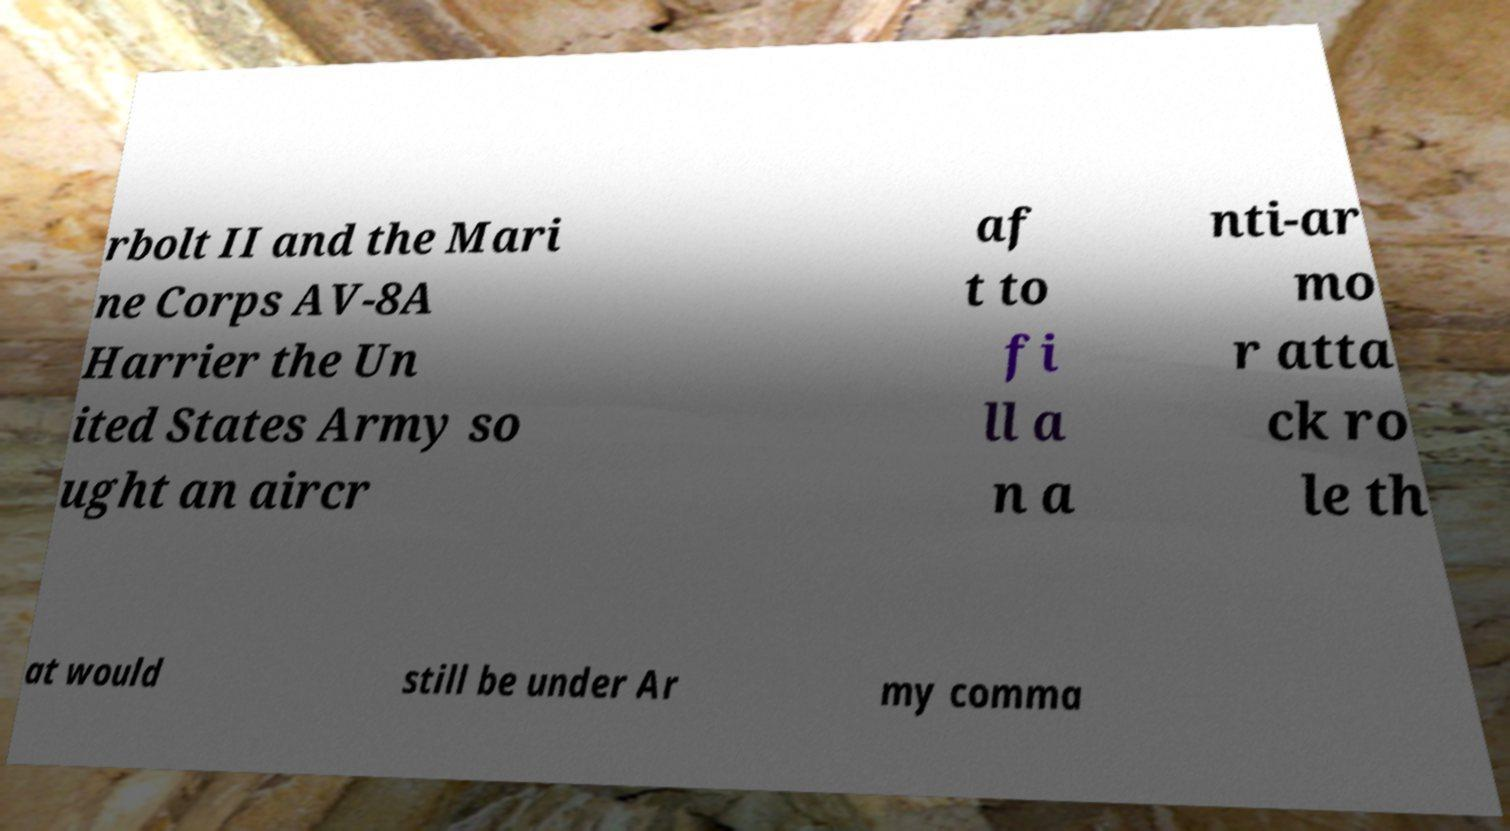What messages or text are displayed in this image? I need them in a readable, typed format. rbolt II and the Mari ne Corps AV-8A Harrier the Un ited States Army so ught an aircr af t to fi ll a n a nti-ar mo r atta ck ro le th at would still be under Ar my comma 